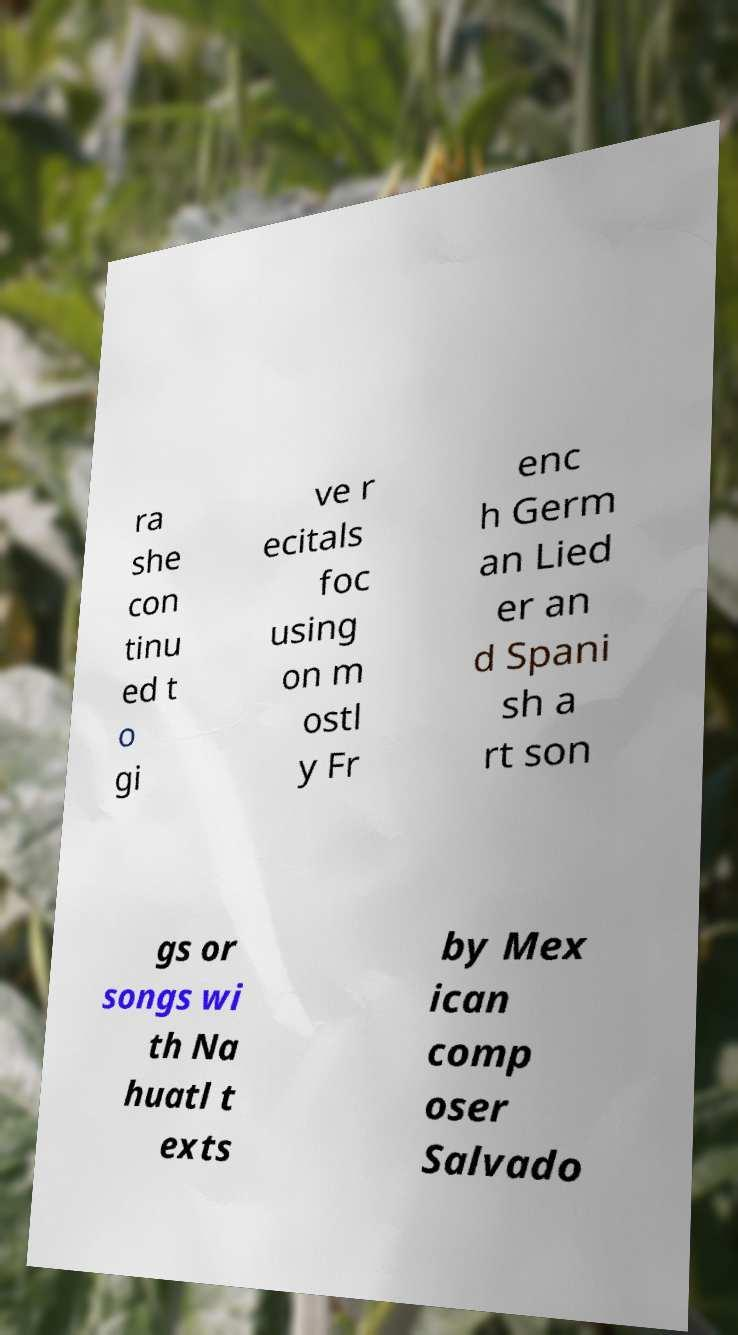Can you read and provide the text displayed in the image?This photo seems to have some interesting text. Can you extract and type it out for me? ra she con tinu ed t o gi ve r ecitals foc using on m ostl y Fr enc h Germ an Lied er an d Spani sh a rt son gs or songs wi th Na huatl t exts by Mex ican comp oser Salvado 